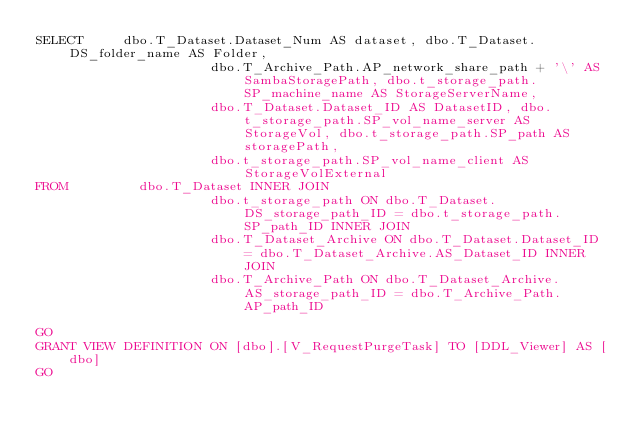Convert code to text. <code><loc_0><loc_0><loc_500><loc_500><_SQL_>SELECT     dbo.T_Dataset.Dataset_Num AS dataset, dbo.T_Dataset.DS_folder_name AS Folder, 
                      dbo.T_Archive_Path.AP_network_share_path + '\' AS SambaStoragePath, dbo.t_storage_path.SP_machine_name AS StorageServerName, 
                      dbo.T_Dataset.Dataset_ID AS DatasetID, dbo.t_storage_path.SP_vol_name_server AS StorageVol, dbo.t_storage_path.SP_path AS storagePath, 
                      dbo.t_storage_path.SP_vol_name_client AS StorageVolExternal
FROM         dbo.T_Dataset INNER JOIN
                      dbo.t_storage_path ON dbo.T_Dataset.DS_storage_path_ID = dbo.t_storage_path.SP_path_ID INNER JOIN
                      dbo.T_Dataset_Archive ON dbo.T_Dataset.Dataset_ID = dbo.T_Dataset_Archive.AS_Dataset_ID INNER JOIN
                      dbo.T_Archive_Path ON dbo.T_Dataset_Archive.AS_storage_path_ID = dbo.T_Archive_Path.AP_path_ID

GO
GRANT VIEW DEFINITION ON [dbo].[V_RequestPurgeTask] TO [DDL_Viewer] AS [dbo]
GO
</code> 